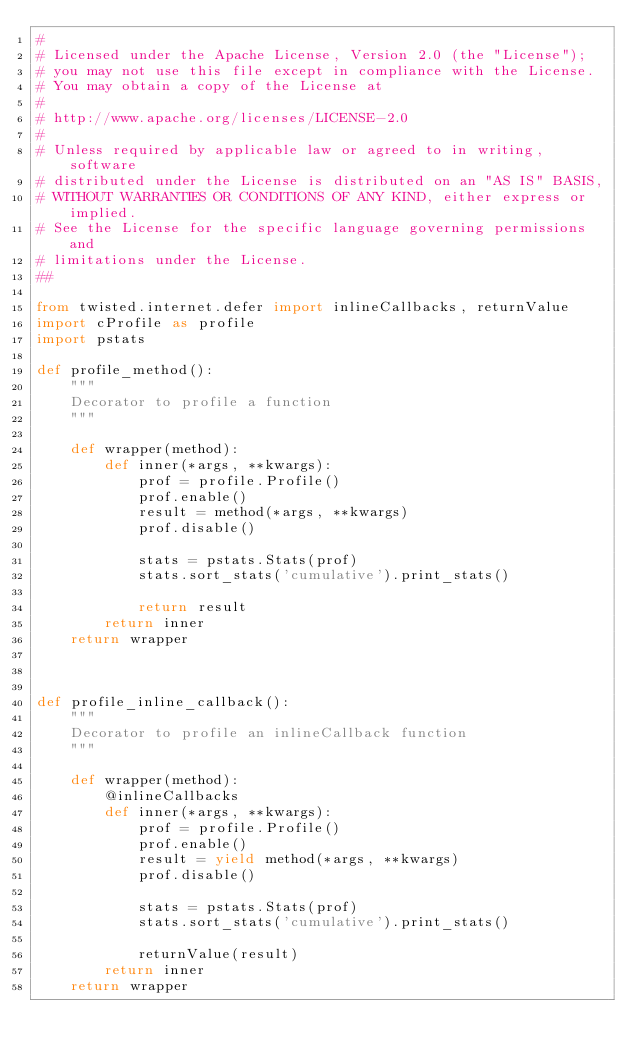<code> <loc_0><loc_0><loc_500><loc_500><_Python_>#
# Licensed under the Apache License, Version 2.0 (the "License");
# you may not use this file except in compliance with the License.
# You may obtain a copy of the License at
#
# http://www.apache.org/licenses/LICENSE-2.0
#
# Unless required by applicable law or agreed to in writing, software
# distributed under the License is distributed on an "AS IS" BASIS,
# WITHOUT WARRANTIES OR CONDITIONS OF ANY KIND, either express or implied.
# See the License for the specific language governing permissions and
# limitations under the License.
##

from twisted.internet.defer import inlineCallbacks, returnValue
import cProfile as profile
import pstats

def profile_method():
    """
    Decorator to profile a function
    """

    def wrapper(method):
        def inner(*args, **kwargs):
            prof = profile.Profile()
            prof.enable()
            result = method(*args, **kwargs)
            prof.disable()

            stats = pstats.Stats(prof)
            stats.sort_stats('cumulative').print_stats()

            return result
        return inner
    return wrapper



def profile_inline_callback():
    """
    Decorator to profile an inlineCallback function
    """

    def wrapper(method):
        @inlineCallbacks
        def inner(*args, **kwargs):
            prof = profile.Profile()
            prof.enable()
            result = yield method(*args, **kwargs)
            prof.disable()

            stats = pstats.Stats(prof)
            stats.sort_stats('cumulative').print_stats()

            returnValue(result)
        return inner
    return wrapper
</code> 